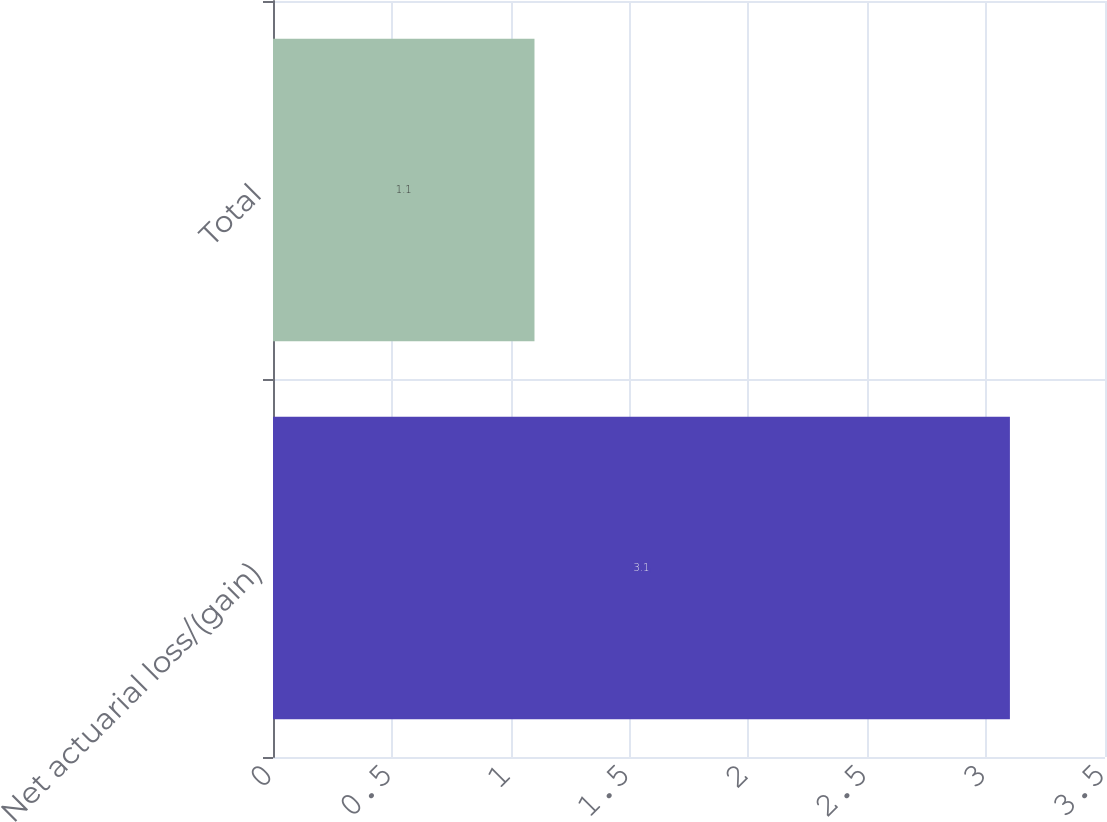Convert chart. <chart><loc_0><loc_0><loc_500><loc_500><bar_chart><fcel>Net actuarial loss/(gain)<fcel>Total<nl><fcel>3.1<fcel>1.1<nl></chart> 